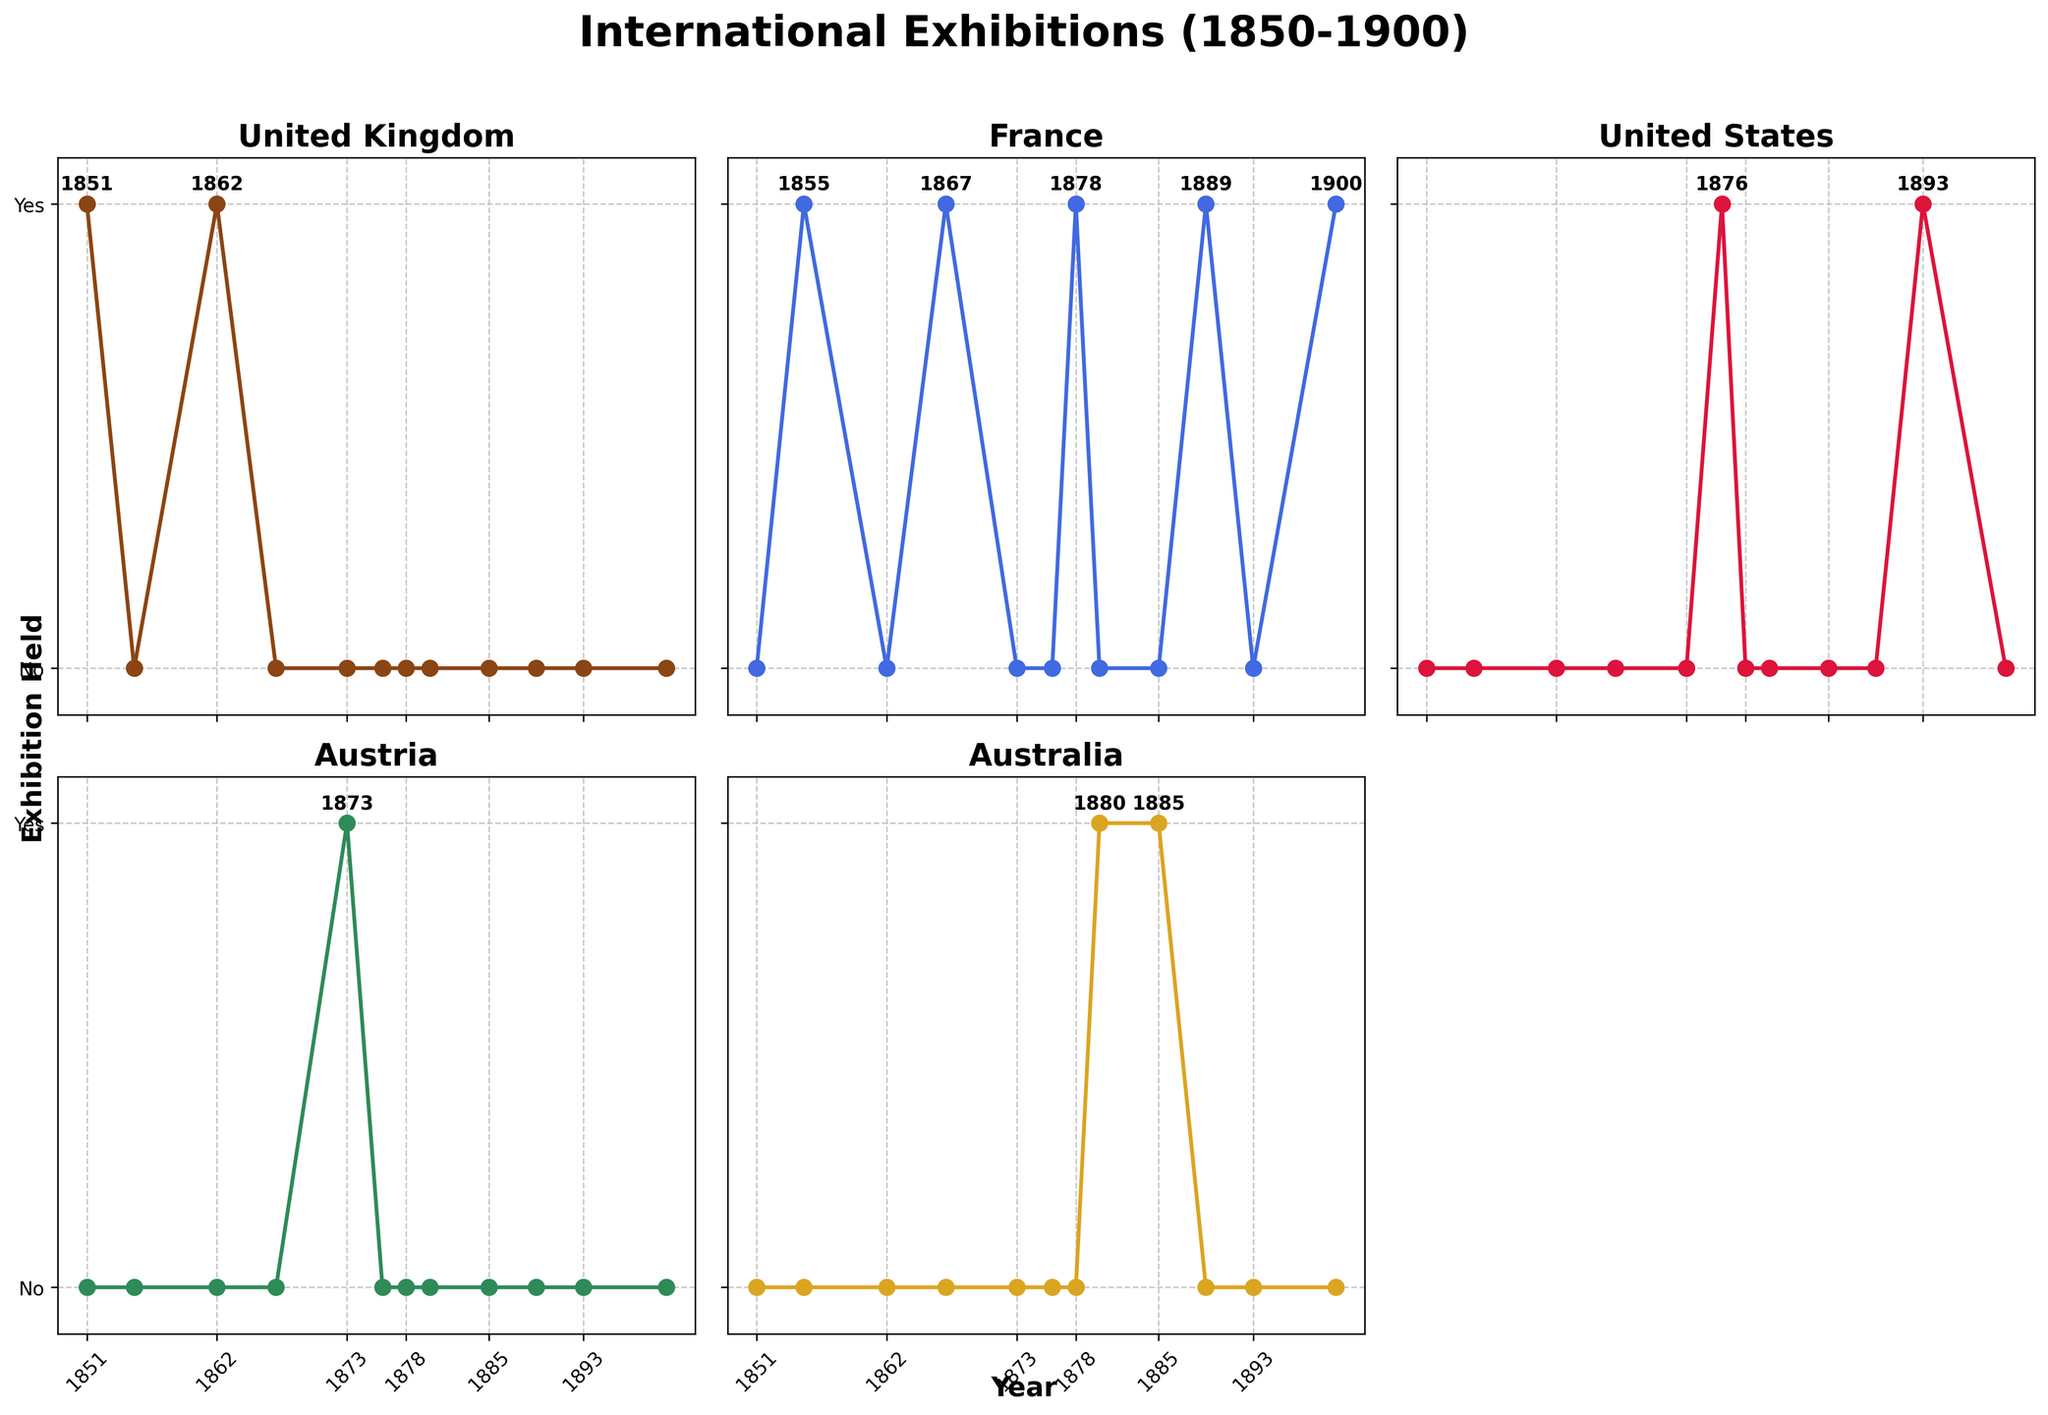What is the title of the entire figure? The title of the figure is prominently displayed at the top, above all the subplots.
Answer: "International Exhibitions (1850-1900)" Which country held the first international exhibition according to the figure? By examining the subplots, the United Kingdom has an exhibition marked at the year 1851.
Answer: United Kingdom How many countries held international exhibitions in the year 1889? Check the data points for 1889 in each subplot. Only France has an exhibition marked for that year.
Answer: 1 Which country hosted the most international exhibitions between 1850 and 1900? Count the number of exhibitions for each country by tallying the data points marked with a 'Yes'. France has the most with five exhibitions.
Answer: France Did Australia ever hold an international exhibition before 1880? Look at the subplot for Australia and observe the years before 1880. No exhibition is marked.
Answer: No How many total international exhibitions were held by the United Kingdom and the United States combined in this period? Count the exhibitions for the United Kingdom (2) and the United States (2) and sum them.
Answer: 4 Among the listed countries, which one had the longest interval between two consecutive international exhibitions? Calculate the intervals between consecutive exhibitions for each country. The United States had a 17-year interval between 1876 and 1893.
Answer: United States What years did Austria hold international exhibitions according to the figure? Identify the year(s) at which the data points for Austria are marked as 'Yes'. There is only one year, 1873.
Answer: 1873 Compare the frequency of international exhibitions held by France and Australia. Which one is greater? Count the number of exhibitions for both France (5) and Australia (2). France has a greater frequency.
Answer: France What trend can you observe about the year spacing of international exhibitions in the United States? Note the years 1876 and 1893. There is a gap of 17 years between the two exhibitions. The trend suggests sparse occurrences.
Answer: Sparse, 17-year interval 